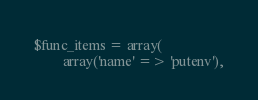Convert code to text. <code><loc_0><loc_0><loc_500><loc_500><_PHP_>$func_items = array(
        array('name' => 'putenv'),</code> 